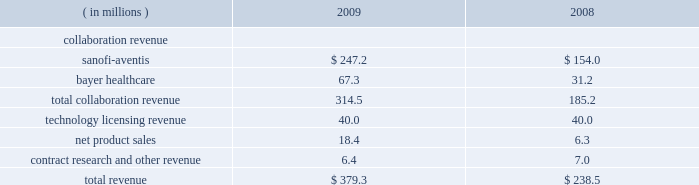Selling , general , and administrative expenses selling , general , and administrative expenses increased to $ 65.2 million in 2010 from $ 52.9 million in 2009 due primarily to increases in compensation expense and recruitment costs , principally in connection with higher headcount in 2010 , and an increase in non-cash compensation expense for the reasons described above .
Cost of goods sold cost of goods sold in 2010 and 2009 was $ 2.1 million and $ 1.7 million , respectively , and consisted primarily of royalties and other period costs related to arcalyst ae commercial supplies .
To date , arcalyst ae shipments to our customers have primarily consisted of supplies of inventory manufactured and expensed as research and development costs prior to fda approval in 2008 ; therefore , the costs of these supplies were not included in costs of goods sold .
Other income and expense investment income decreased to $ 2.1 million in 2010 from $ 4.5 million in 2009 , due primarily to lower yields on , and lower average balances of , cash and marketable securities .
Interest expense increased to $ 9.1 million in 2010 from $ 2.3 million in 2009 .
Interest expense is primarily attributable to the imputed interest portion of payments to our landlord , commencing in the third quarter of 2009 , to lease newly constructed laboratory and office facilities in tarrytown , new york .
Income tax expense ( benefit ) in 2010 , we did not recognize any income tax expense or benefit .
In 2009 , we recognized a $ 4.1 million income tax benefit , consisting primarily of ( i ) $ 2.7 million resulting from a provision in the worker , homeownership , and business assistance act of 2009 that allowed us to claim a refund of u.s .
Federal alternative minimum tax that we paid in 2008 , and ( ii ) $ 0.7 million resulting from a provision in the american recovery and reinvestment act of 2009 that allowed us to claim a refund for a portion of our unused pre-2006 research tax credits .
Years ended december 31 , 2009 and 2008 net loss regeneron reported a net loss of $ 67.8 million , or $ 0.85 per share ( basic and diluted ) , for the year ended december 31 , 2009 , compared to a net loss of $ 79.1 million , or $ 1.00 per share ( basic and diluted ) for 2008 .
The decrease in our net loss in 2009 was principally due to higher collaboration revenue in connection with our antibody collaboration with sanofi-aventis , receipt of a $ 20.0 million substantive performance milestone payment in connection with our vegf trap-eye collaboration with bayer healthcare , and higher arcalyst ae sales , partly offset by higher research and development expenses , as detailed below .
Revenues revenues in 2009 and 2008 consist of the following: .

What percentage of total revenue was bayer healthcare in 2009? 
Computations: (67.3 / 379.3)
Answer: 0.17743. 